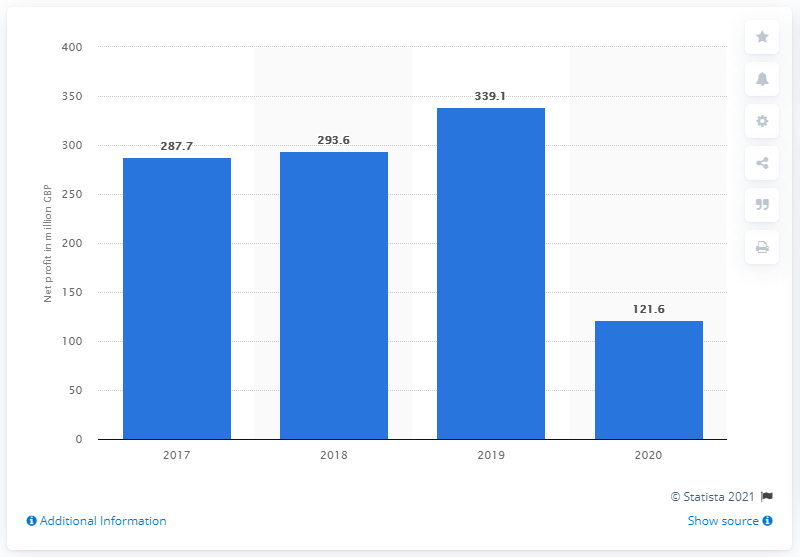Highlight a few significant elements in this photo. In 2020, Burberry's net profit was 121.6 million. 